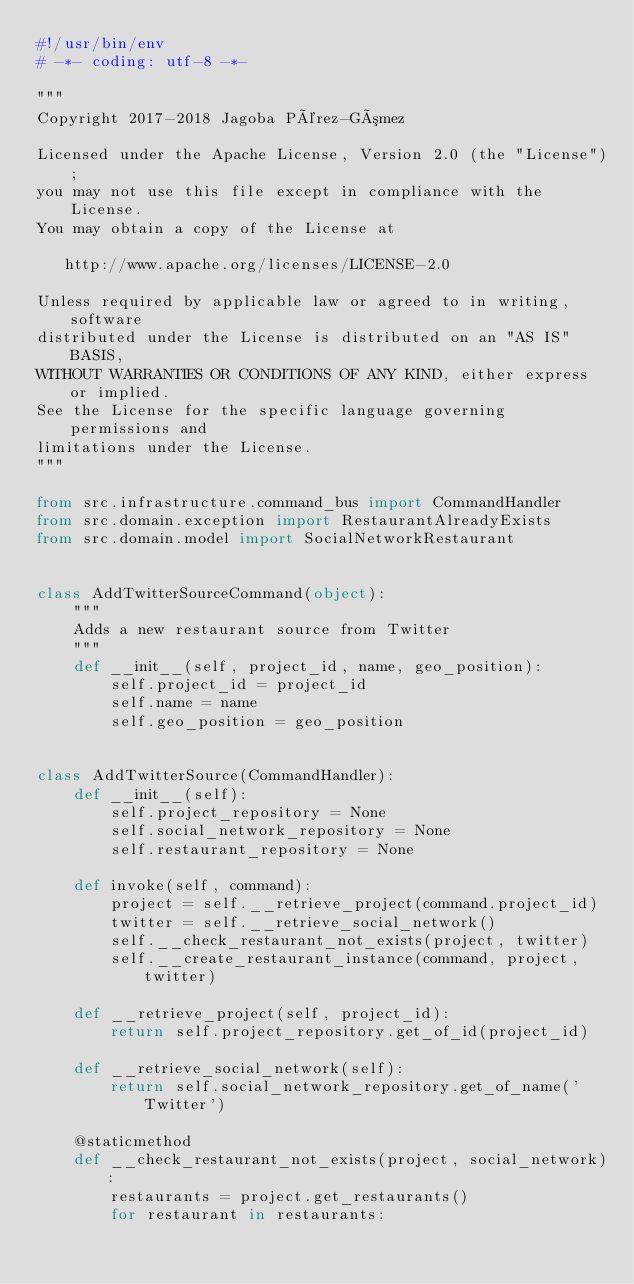<code> <loc_0><loc_0><loc_500><loc_500><_Python_>#!/usr/bin/env
# -*- coding: utf-8 -*-

"""
Copyright 2017-2018 Jagoba Pérez-Gómez

Licensed under the Apache License, Version 2.0 (the "License");
you may not use this file except in compliance with the License.
You may obtain a copy of the License at

   http://www.apache.org/licenses/LICENSE-2.0

Unless required by applicable law or agreed to in writing, software
distributed under the License is distributed on an "AS IS" BASIS,
WITHOUT WARRANTIES OR CONDITIONS OF ANY KIND, either express or implied.
See the License for the specific language governing permissions and
limitations under the License.
"""

from src.infrastructure.command_bus import CommandHandler
from src.domain.exception import RestaurantAlreadyExists
from src.domain.model import SocialNetworkRestaurant


class AddTwitterSourceCommand(object):
    """
    Adds a new restaurant source from Twitter
    """
    def __init__(self, project_id, name, geo_position):
        self.project_id = project_id
        self.name = name
        self.geo_position = geo_position


class AddTwitterSource(CommandHandler):
    def __init__(self):
        self.project_repository = None
        self.social_network_repository = None
        self.restaurant_repository = None

    def invoke(self, command):
        project = self.__retrieve_project(command.project_id)
        twitter = self.__retrieve_social_network()
        self.__check_restaurant_not_exists(project, twitter)
        self.__create_restaurant_instance(command, project, twitter)

    def __retrieve_project(self, project_id):
        return self.project_repository.get_of_id(project_id)

    def __retrieve_social_network(self):
        return self.social_network_repository.get_of_name('Twitter')

    @staticmethod
    def __check_restaurant_not_exists(project, social_network):
        restaurants = project.get_restaurants()
        for restaurant in restaurants:</code> 